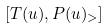Convert formula to latex. <formula><loc_0><loc_0><loc_500><loc_500>[ T ( u ) , P ( u ) _ { > } ]</formula> 